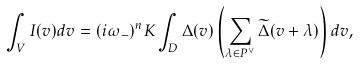Convert formula to latex. <formula><loc_0><loc_0><loc_500><loc_500>\int _ { V } I ( v ) d v = ( i \omega _ { - } ) ^ { n } K \int _ { D } \Delta ( v ) \left ( \sum _ { \lambda \in P ^ { \vee } } \widetilde { \Delta } ( v + \lambda ) \right ) d v ,</formula> 